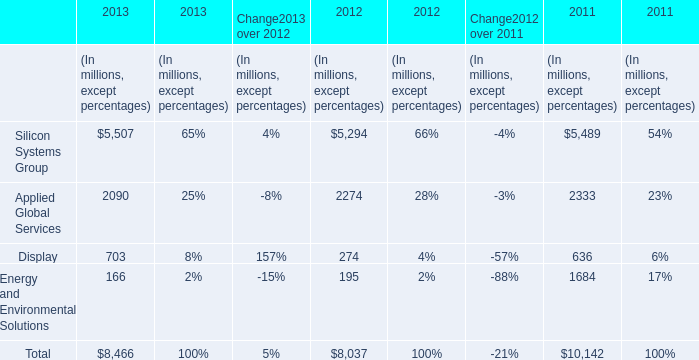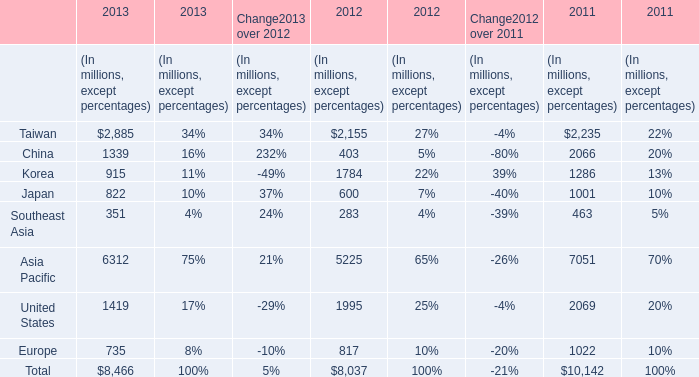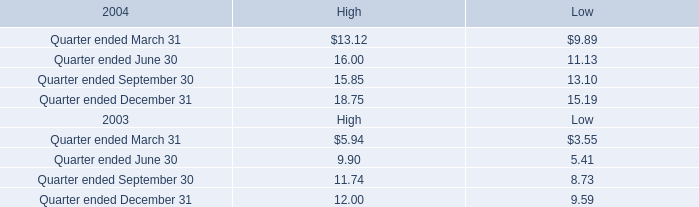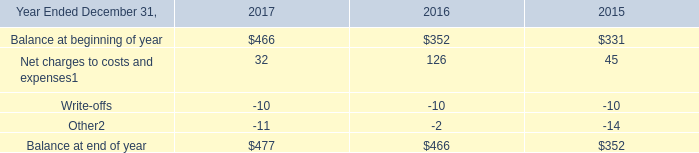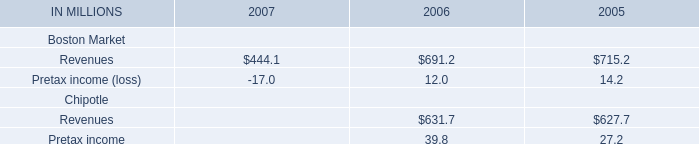What's the total amount of the Taiwan in table 1 in the years where Taiwan is greater than 2800? (in millons) 
Answer: 2885. 